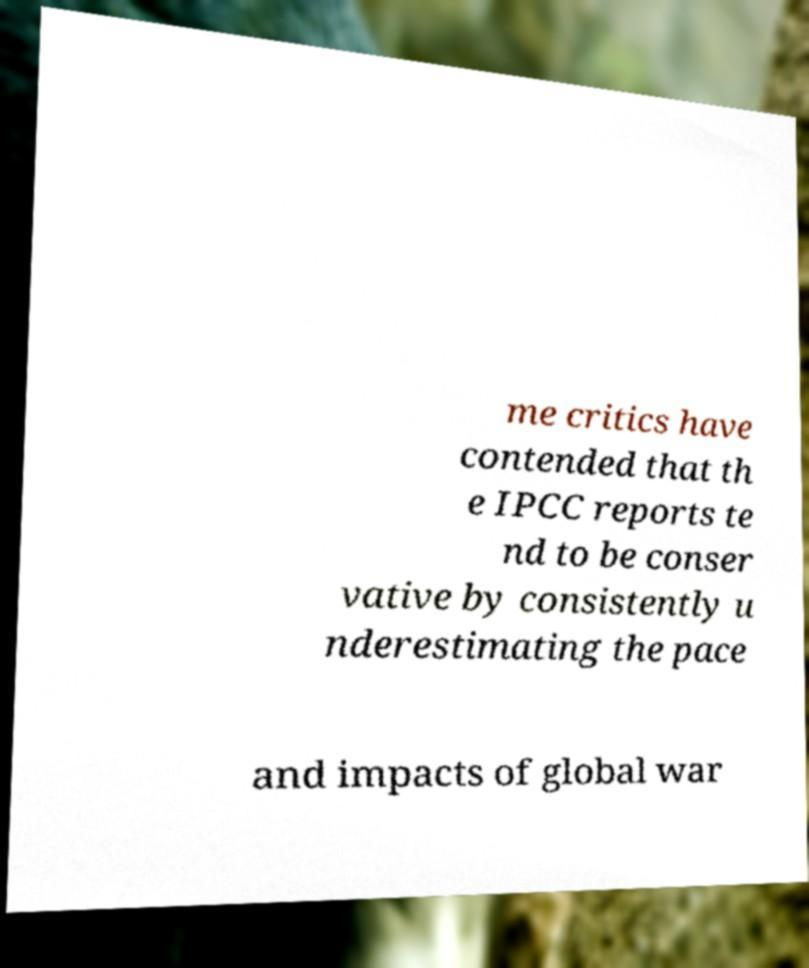Please identify and transcribe the text found in this image. me critics have contended that th e IPCC reports te nd to be conser vative by consistently u nderestimating the pace and impacts of global war 